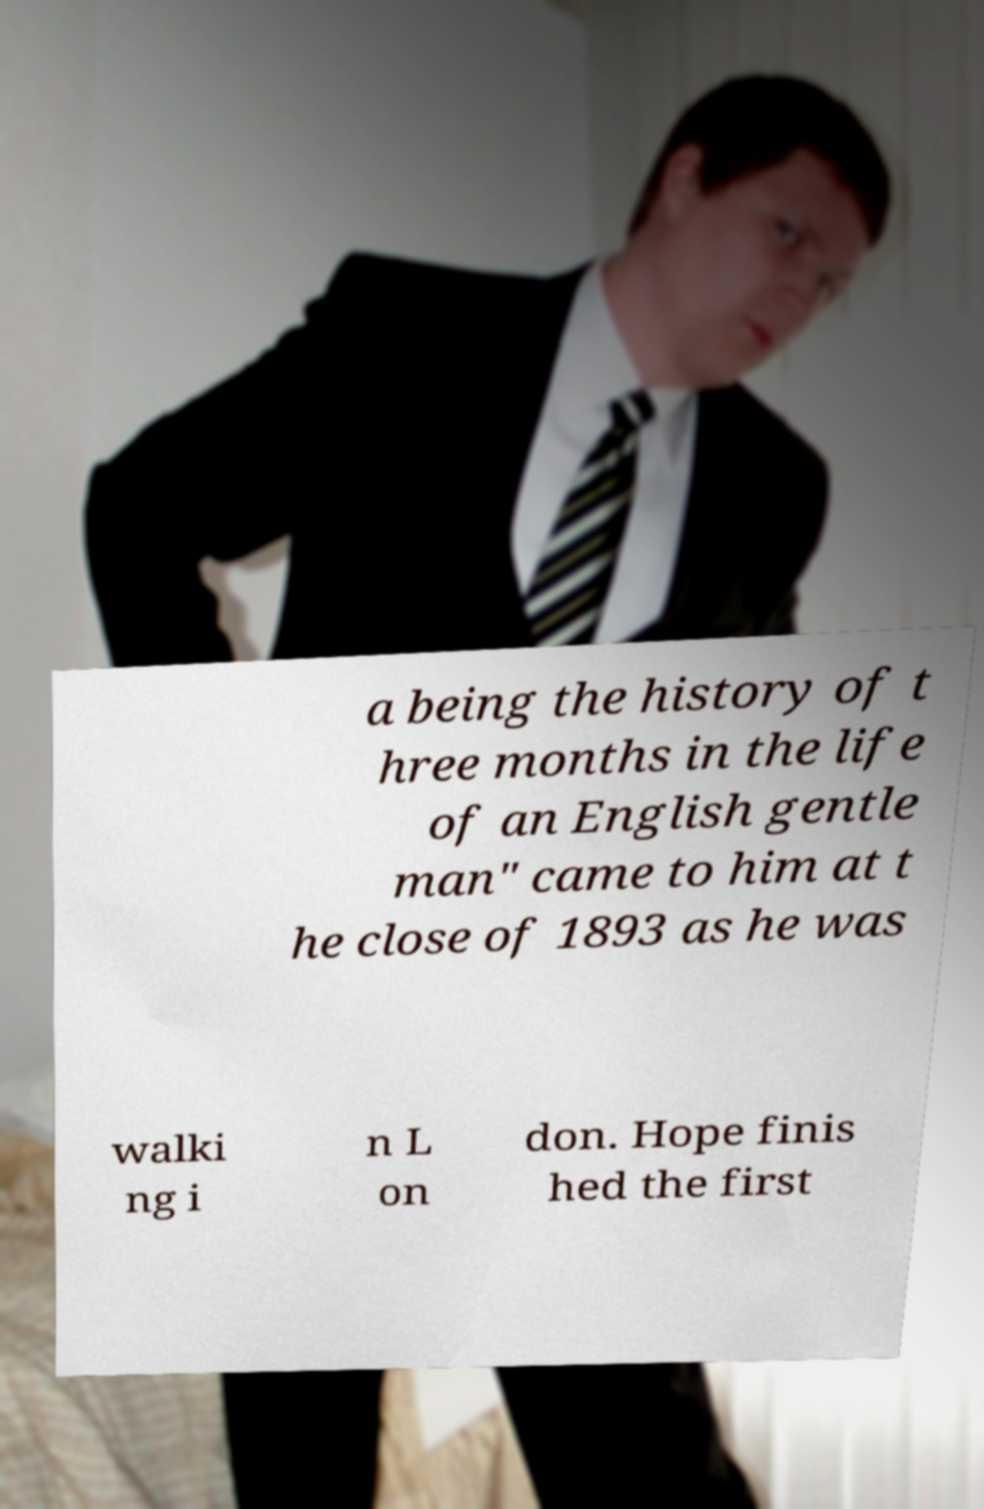What messages or text are displayed in this image? I need them in a readable, typed format. a being the history of t hree months in the life of an English gentle man" came to him at t he close of 1893 as he was walki ng i n L on don. Hope finis hed the first 